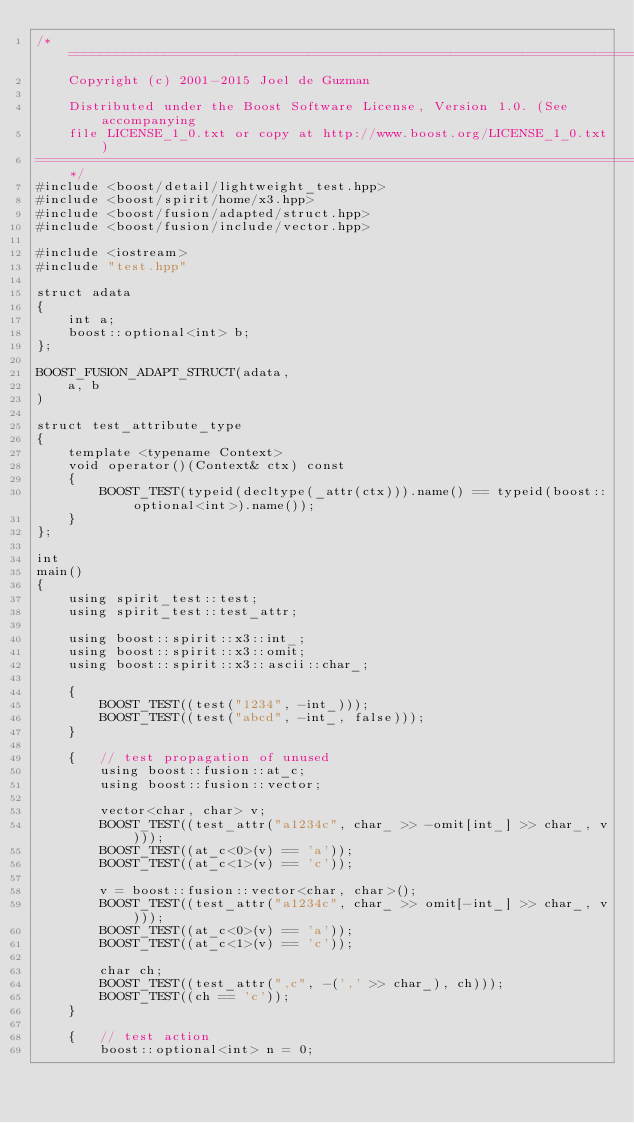<code> <loc_0><loc_0><loc_500><loc_500><_C++_>/*=============================================================================
    Copyright (c) 2001-2015 Joel de Guzman

    Distributed under the Boost Software License, Version 1.0. (See accompanying
    file LICENSE_1_0.txt or copy at http://www.boost.org/LICENSE_1_0.txt)
=============================================================================*/
#include <boost/detail/lightweight_test.hpp>
#include <boost/spirit/home/x3.hpp>
#include <boost/fusion/adapted/struct.hpp>
#include <boost/fusion/include/vector.hpp>

#include <iostream>
#include "test.hpp"

struct adata
{
    int a;
    boost::optional<int> b;
};

BOOST_FUSION_ADAPT_STRUCT(adata,
    a, b
)

struct test_attribute_type
{
    template <typename Context>
    void operator()(Context& ctx) const
    {
        BOOST_TEST(typeid(decltype(_attr(ctx))).name() == typeid(boost::optional<int>).name());
    }
};

int
main()
{
    using spirit_test::test;
    using spirit_test::test_attr;

    using boost::spirit::x3::int_;
    using boost::spirit::x3::omit;
    using boost::spirit::x3::ascii::char_;

    {
        BOOST_TEST((test("1234", -int_)));
        BOOST_TEST((test("abcd", -int_, false)));
    }

    {   // test propagation of unused
        using boost::fusion::at_c;
        using boost::fusion::vector;

        vector<char, char> v;
        BOOST_TEST((test_attr("a1234c", char_ >> -omit[int_] >> char_, v)));
        BOOST_TEST((at_c<0>(v) == 'a'));
        BOOST_TEST((at_c<1>(v) == 'c'));

        v = boost::fusion::vector<char, char>();
        BOOST_TEST((test_attr("a1234c", char_ >> omit[-int_] >> char_, v)));
        BOOST_TEST((at_c<0>(v) == 'a'));
        BOOST_TEST((at_c<1>(v) == 'c'));

        char ch;
        BOOST_TEST((test_attr(",c", -(',' >> char_), ch)));
        BOOST_TEST((ch == 'c'));
    }

    {   // test action
        boost::optional<int> n = 0;</code> 